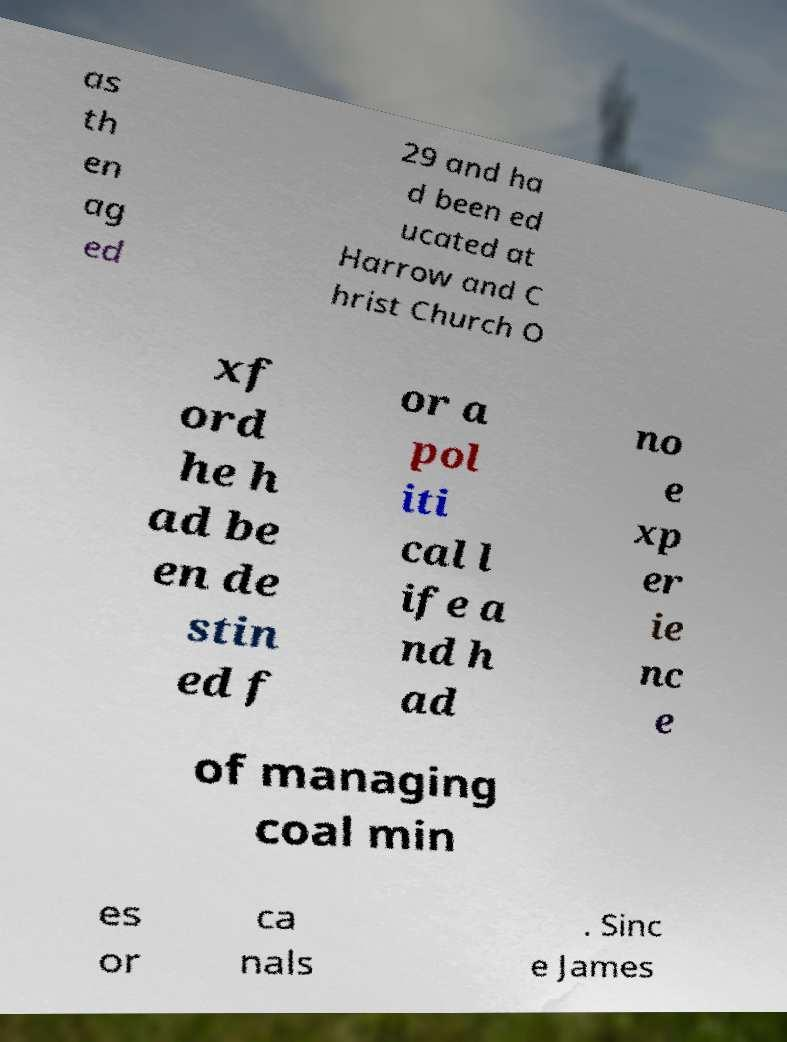For documentation purposes, I need the text within this image transcribed. Could you provide that? as th en ag ed 29 and ha d been ed ucated at Harrow and C hrist Church O xf ord he h ad be en de stin ed f or a pol iti cal l ife a nd h ad no e xp er ie nc e of managing coal min es or ca nals . Sinc e James 